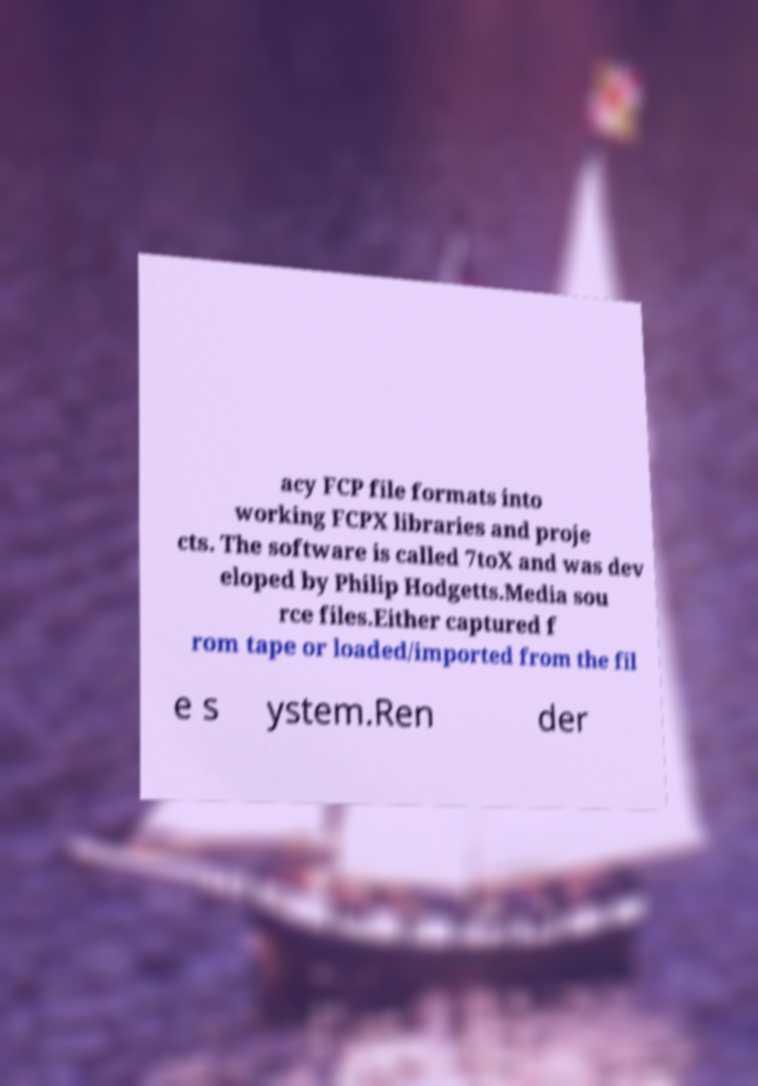I need the written content from this picture converted into text. Can you do that? acy FCP file formats into working FCPX libraries and proje cts. The software is called 7toX and was dev eloped by Philip Hodgetts.Media sou rce files.Either captured f rom tape or loaded/imported from the fil e s ystem.Ren der 